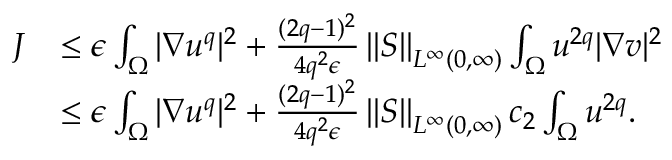<formula> <loc_0><loc_0><loc_500><loc_500>\begin{array} { r l } { J } & { \leq \epsilon \int _ { \Omega } | \nabla u ^ { q } | ^ { 2 } + \frac { ( 2 q - 1 ) ^ { 2 } } { 4 q ^ { 2 } \epsilon } \left \| S \right \| _ { L ^ { \infty } ( 0 , \infty ) } \int _ { \Omega } u ^ { 2 q } | \nabla v | ^ { 2 } } \\ & { \leq \epsilon \int _ { \Omega } | \nabla u ^ { q } | ^ { 2 } + \frac { ( 2 q - 1 ) ^ { 2 } } { 4 q ^ { 2 } \epsilon } \left \| S \right \| _ { L ^ { \infty } ( 0 , \infty ) } c _ { 2 } \int _ { \Omega } u ^ { 2 q } . } \end{array}</formula> 